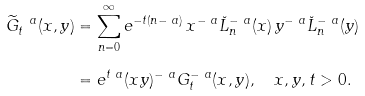Convert formula to latex. <formula><loc_0><loc_0><loc_500><loc_500>\widetilde { G } _ { t } ^ { \ a } ( x , y ) & = \sum _ { n = 0 } ^ { \infty } e ^ { - t ( n - \ a ) } \, x ^ { - \ a } \breve { L } _ { n } ^ { - \ a } ( x ) \, y ^ { - \ a } \breve { L } _ { n } ^ { - \ a } ( y ) \\ & = e ^ { t \ a } ( x y ) ^ { - \ a } G _ { t } ^ { - \ a } ( x , y ) , \quad x , y , t > 0 .</formula> 